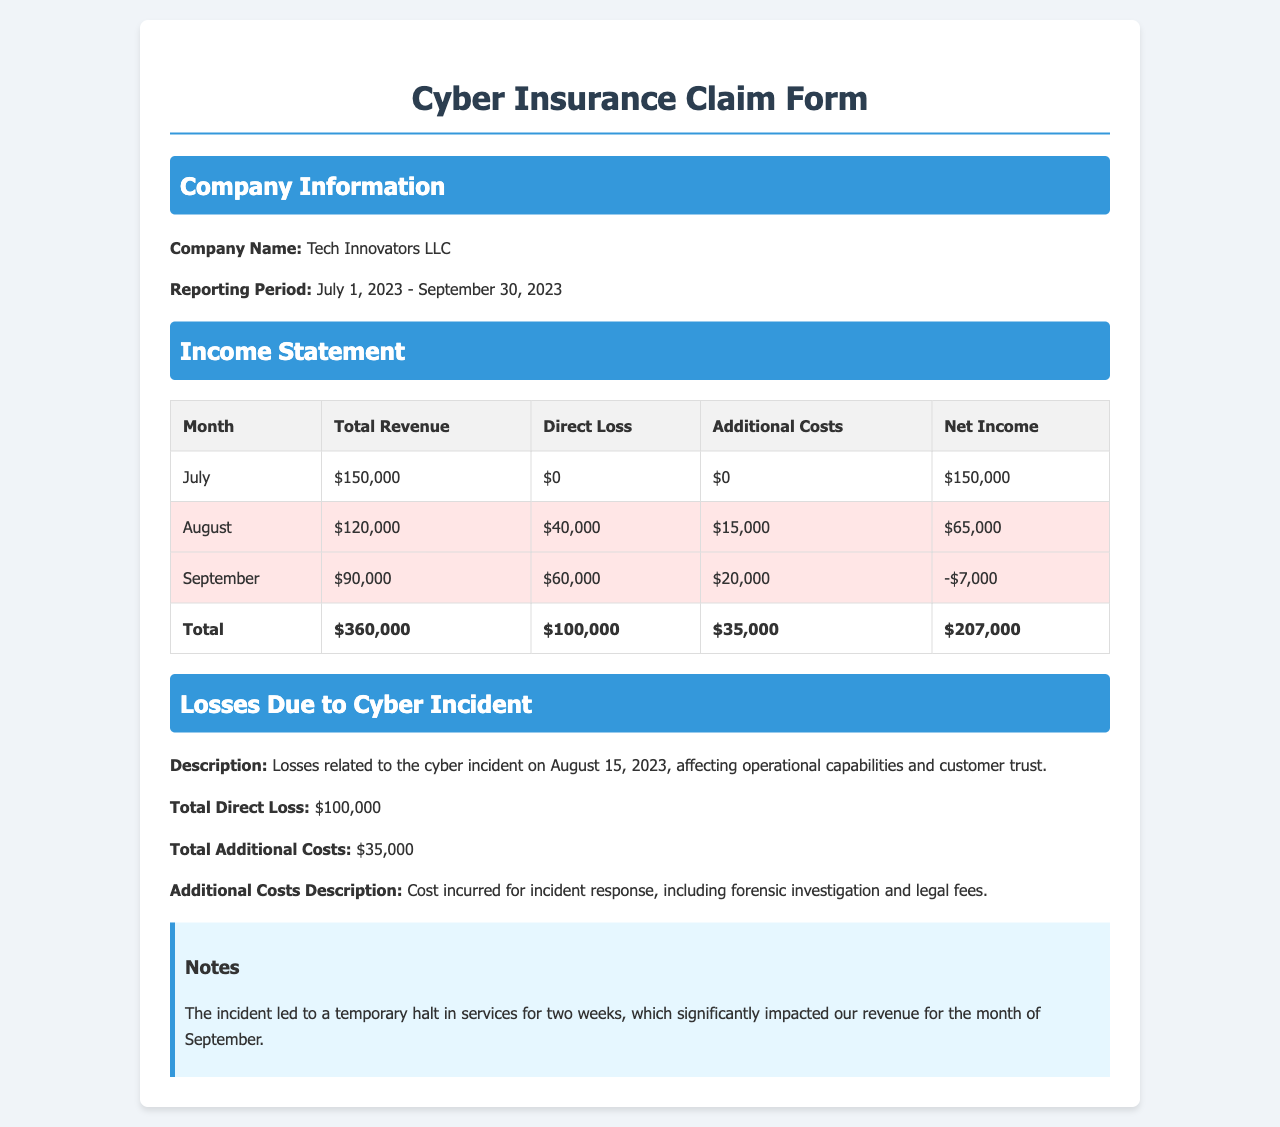What is the company name? The company name is listed under Company Information in the document.
Answer: Tech Innovators LLC What was the total revenue for September? The total revenue for each month is provided in the Income Statement table.
Answer: $90,000 What is the total direct loss attributed to the cyber incident? The total direct loss is specified in the Losses Due to Cyber Incident section.
Answer: $100,000 What additional costs were incurred due to the cyber incident? Additional costs are mentioned in the same section as the direct loss.
Answer: $35,000 How much was the net income for August? Net income figures for each month are available in the Income Statement table.
Answer: $65,000 In which month did the cyber incident occur? The document describes the incident occurring on August 15, 2023.
Answer: August What was the total revenue reported for the three-month period? The total revenue is calculated by summing all monthly revenue figures in the Income Statement.
Answer: $360,000 What description is provided for the losses due to the cyber incident? The description details the effects of the incident on the company's operations and customer trust.
Answer: Losses related to the cyber incident on August 15, 2023, affecting operational capabilities and customer trust What impact did the incident have on services? The document notes the operational effects of the incident, specifically regarding service interruptions.
Answer: Temporary halt in services for two weeks 